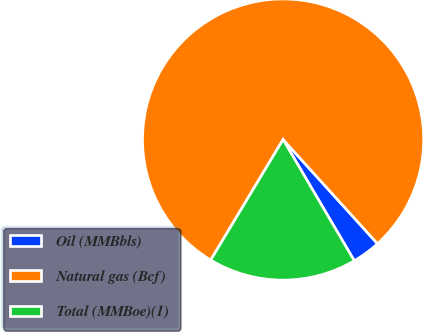Convert chart. <chart><loc_0><loc_0><loc_500><loc_500><pie_chart><fcel>Oil (MMBbls)<fcel>Natural gas (Bcf)<fcel>Total (MMBoe)(1)<nl><fcel>3.27%<fcel>79.67%<fcel>17.06%<nl></chart> 